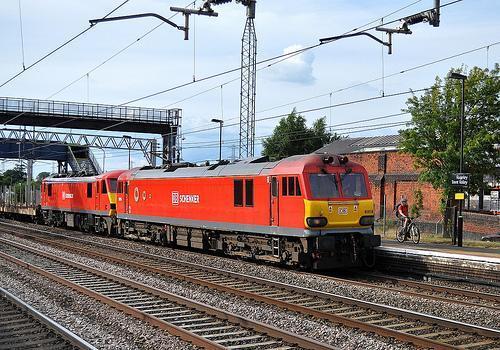How many people are there?
Give a very brief answer. 1. 